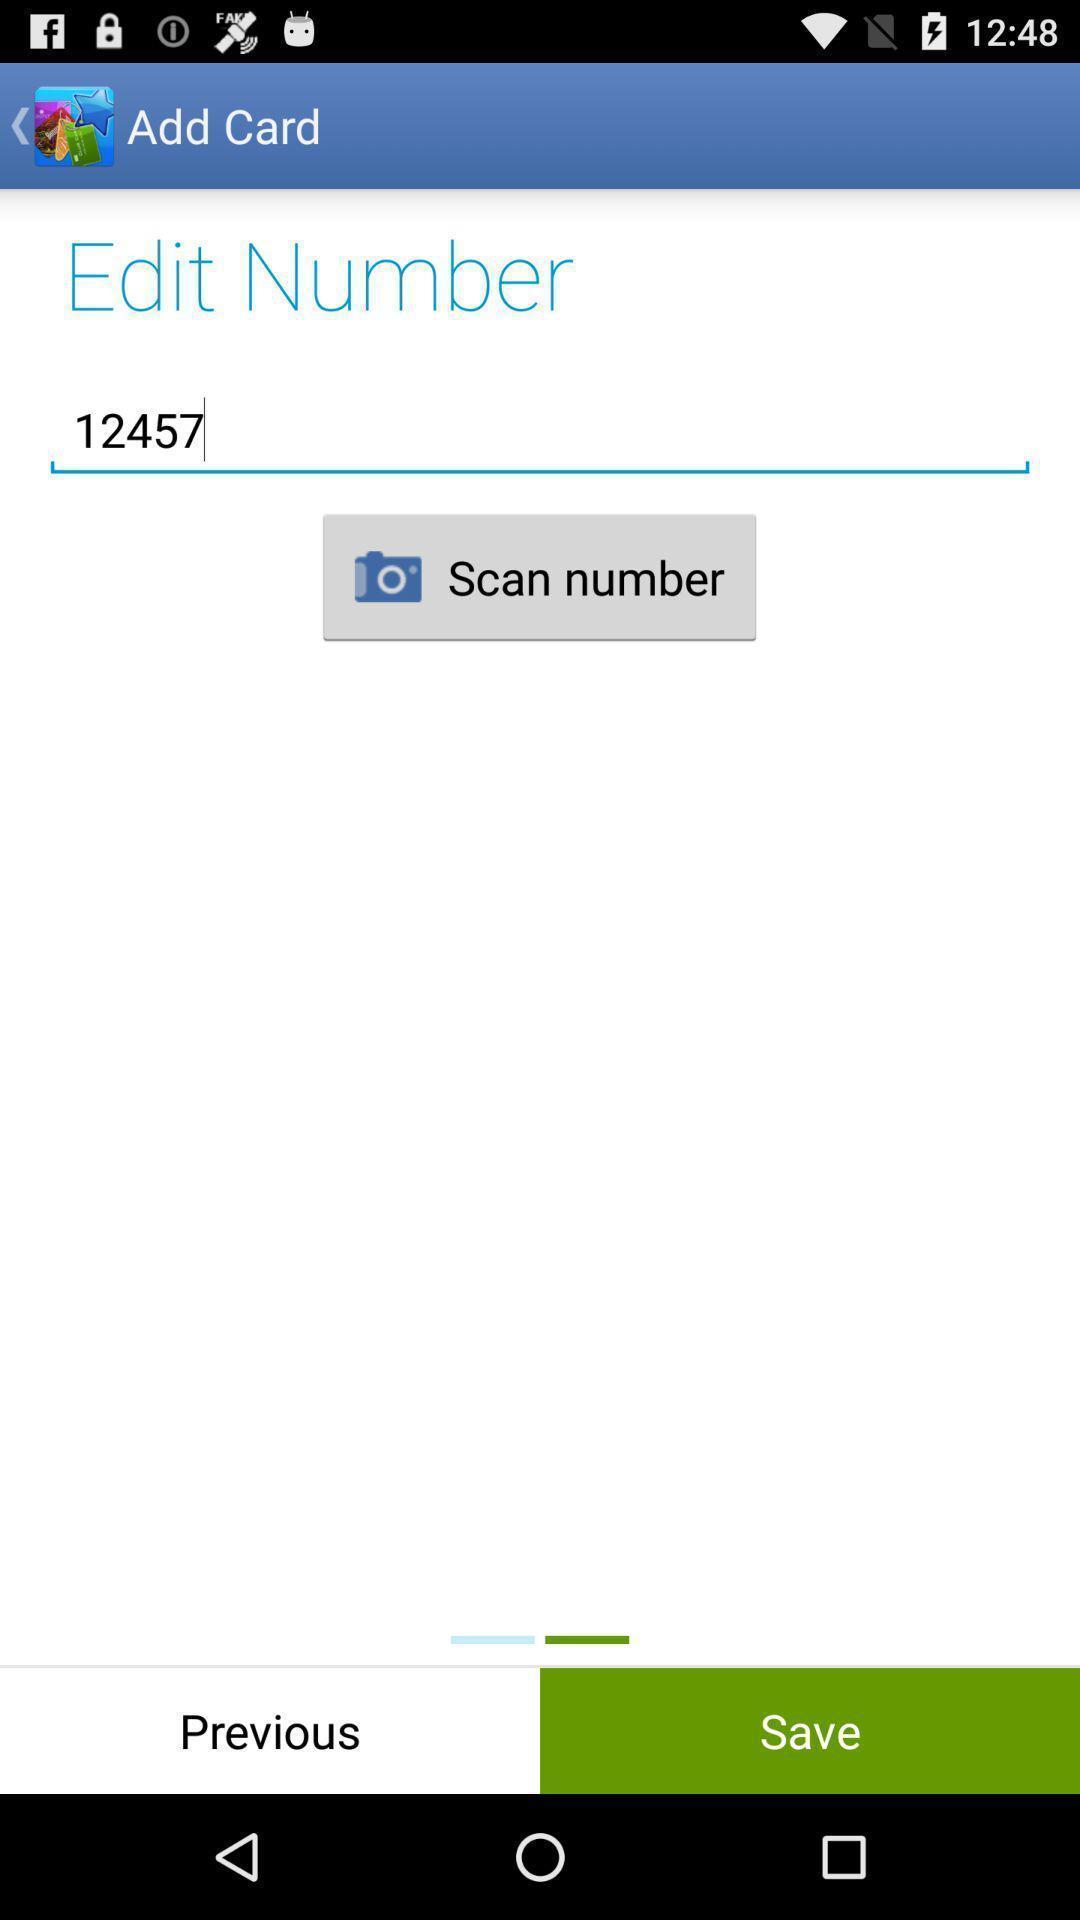What details can you identify in this image? Page shows to edit your card number. 